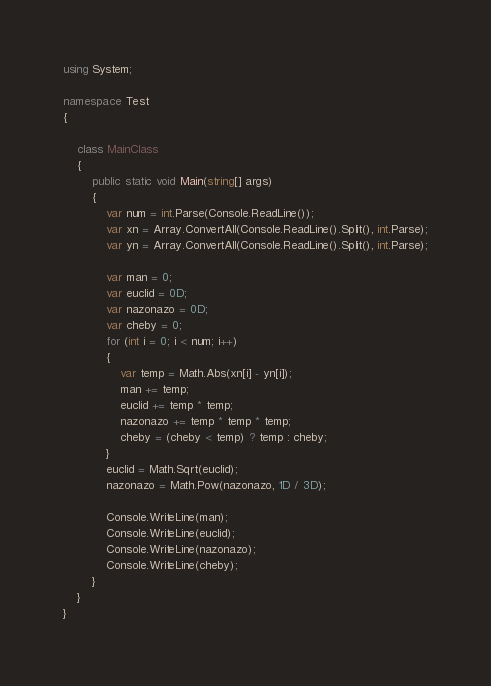Convert code to text. <code><loc_0><loc_0><loc_500><loc_500><_C#_>using System;

namespace Test
{
    
    class MainClass
    {
        public static void Main(string[] args)
        {
            var num = int.Parse(Console.ReadLine());
            var xn = Array.ConvertAll(Console.ReadLine().Split(), int.Parse);
            var yn = Array.ConvertAll(Console.ReadLine().Split(), int.Parse);

            var man = 0;
            var euclid = 0D;
            var nazonazo = 0D;
            var cheby = 0;
            for (int i = 0; i < num; i++)
            {
                var temp = Math.Abs(xn[i] - yn[i]);
                man += temp;
                euclid += temp * temp;
                nazonazo += temp * temp * temp;
                cheby = (cheby < temp) ? temp : cheby;
            }
            euclid = Math.Sqrt(euclid);
            nazonazo = Math.Pow(nazonazo, 1D / 3D);

            Console.WriteLine(man);
            Console.WriteLine(euclid);
            Console.WriteLine(nazonazo);
            Console.WriteLine(cheby);
        }
    }
}</code> 